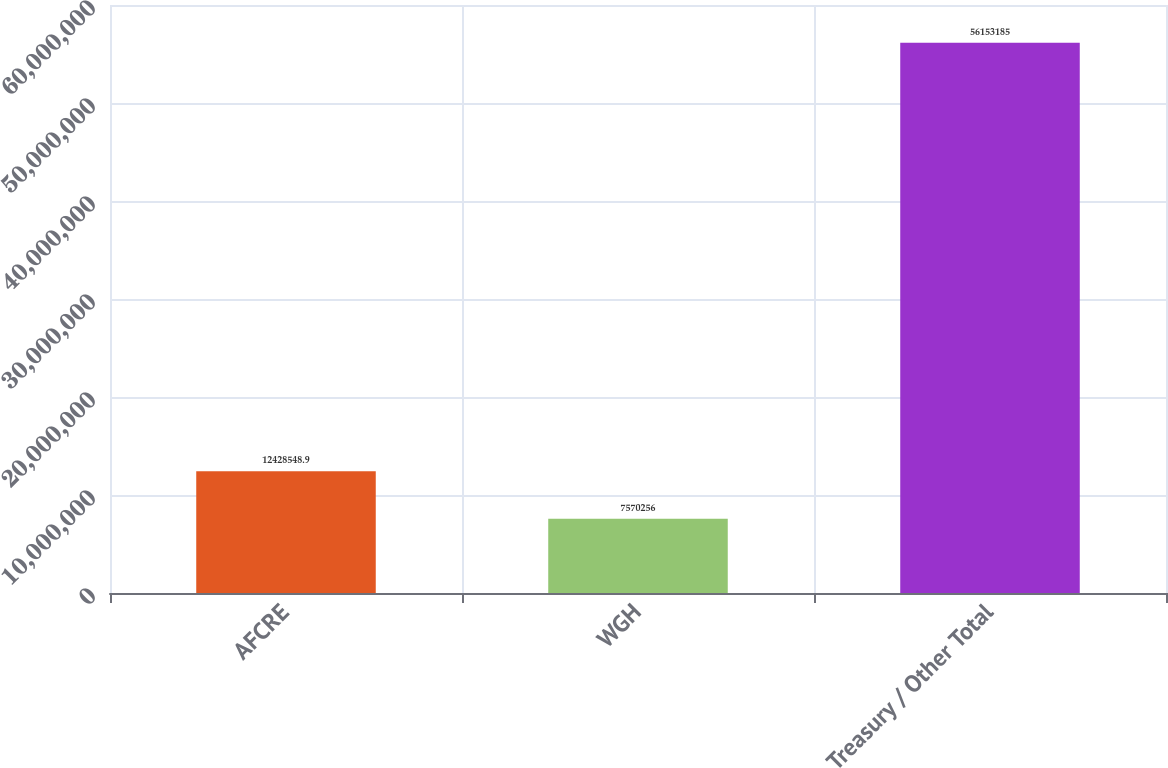Convert chart. <chart><loc_0><loc_0><loc_500><loc_500><bar_chart><fcel>AFCRE<fcel>WGH<fcel>Treasury / Other Total<nl><fcel>1.24285e+07<fcel>7.57026e+06<fcel>5.61532e+07<nl></chart> 